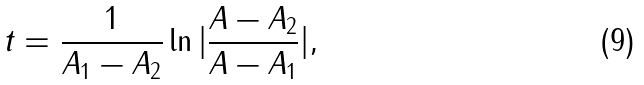<formula> <loc_0><loc_0><loc_500><loc_500>t = \frac { 1 } { A _ { 1 } - A _ { 2 } } \ln | { \frac { A - A _ { 2 } } { A - A _ { 1 } } } | ,</formula> 